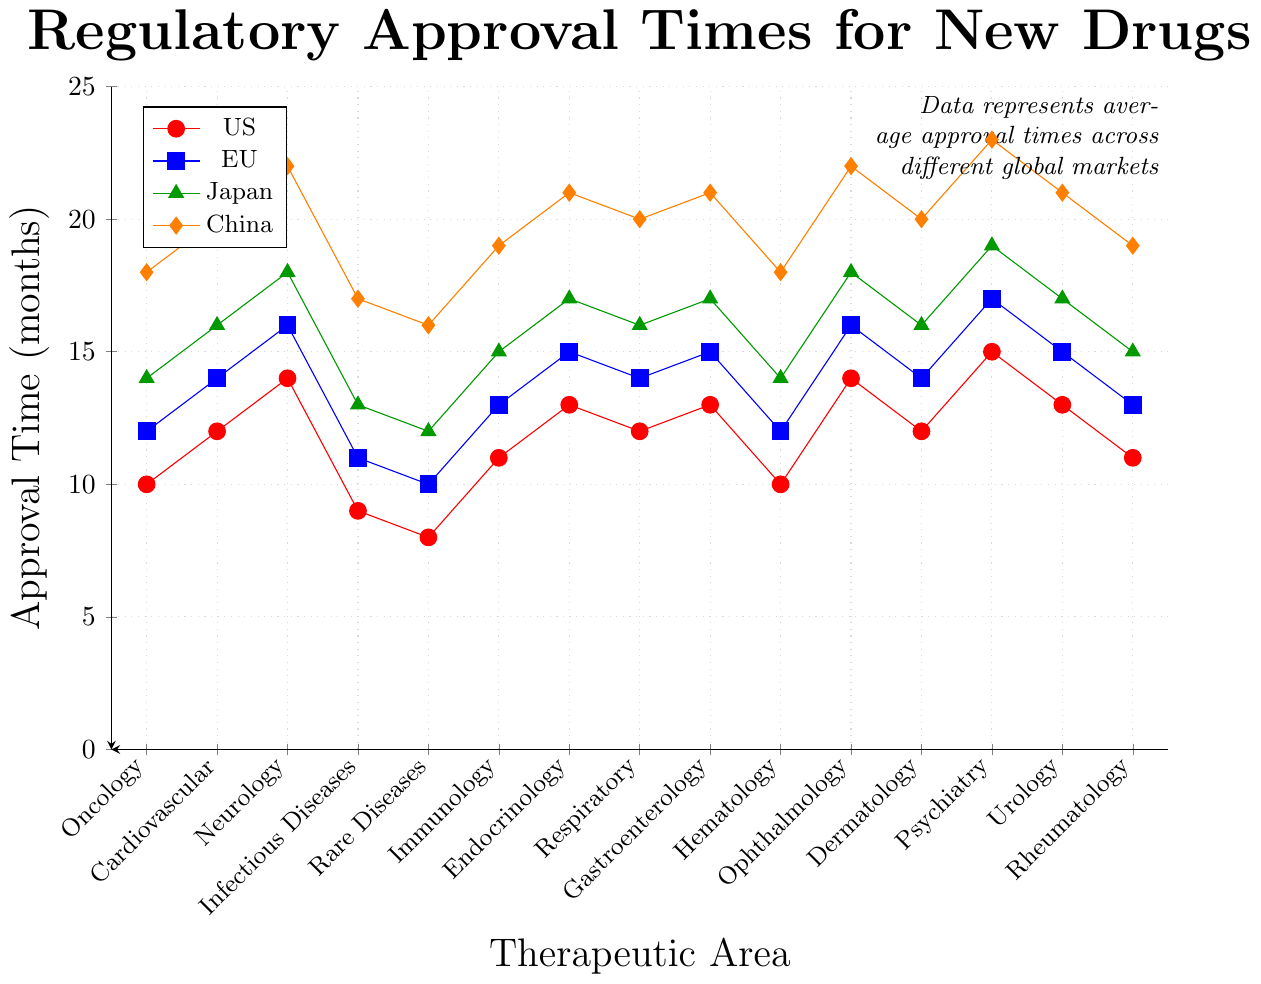Which therapeutic area has the longest approval time in China? Observe the plot to see which therapeutic area corresponds to the highest point in the series labeled "China". Psychiatry has the longest approval time, as its data point reaches up to 23 months.
Answer: Psychiatry Which two therapeutic areas in the US have an approval time of 10 months? Look at the data points in the series labeled "US" that line up with the 10-month mark. Both Oncology and Hematology have approval times of 10 months each in the US.
Answer: Oncology, Hematology In which market is the approval time gap widest between Neurology and Rare Diseases? Calculate the differences between Neurology and Rare Diseases in all markets (US, EU, Japan, China) and compare them. For US: 14 - 8 = 6 months; For EU: 16 - 10 = 6 months; For Japan: 18 - 12 = 6 months; For China: 22 - 16 = 6 months. All markets exhibit the same gap of 6 months.
Answer: All markets have the same 6-month gap What is the average approval time for Endocrinology across all markets? Sum the approval times for Endocrinology in each market and then divide by the number of markets (13 + 15 + 17 + 21). The sum is 66, and divided by 4 gives an average of 16.5 months.
Answer: 16.5 months Which therapeutic area has the smallest difference in approval time between the US and EU? Find the differences between the US and EU times for each therapeutic area and identify the smallest. Rare Diseases have the smallest difference: 10 - 8 = 2 months.
Answer: Rare Diseases Which market has the generally highest approval times across all therapeutic areas? Compare the heights of the series labeled US, EU, Japan, and China across all therapeutic areas. Visually, the China series appears highest for most therapeutic areas.
Answer: China Which therapeutic areas have the same approval time in both the US and EU? Look for data points where the US and EU curves coincide. Oncology, Hematology both have the same approval times of 10 and 12 months respectively.
Answer: Oncology, Hematology How much longer does the regulatory process in China take for Oncology drugs compared to the US? Subtract the US approval time for Oncology from the China approval time for Oncology: 18 - 10 = 8 months.
Answer: 8 months 